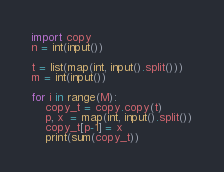Convert code to text. <code><loc_0><loc_0><loc_500><loc_500><_Python_>import copy
n = int(input())

t = list(map(int, input().split()))
m = int(input())

for i in range(M):
    copy_t = copy.copy(t)
    p, x  = map(int, input().split())
    copy_t[p-1] = x
    print(sum(copy_t))</code> 